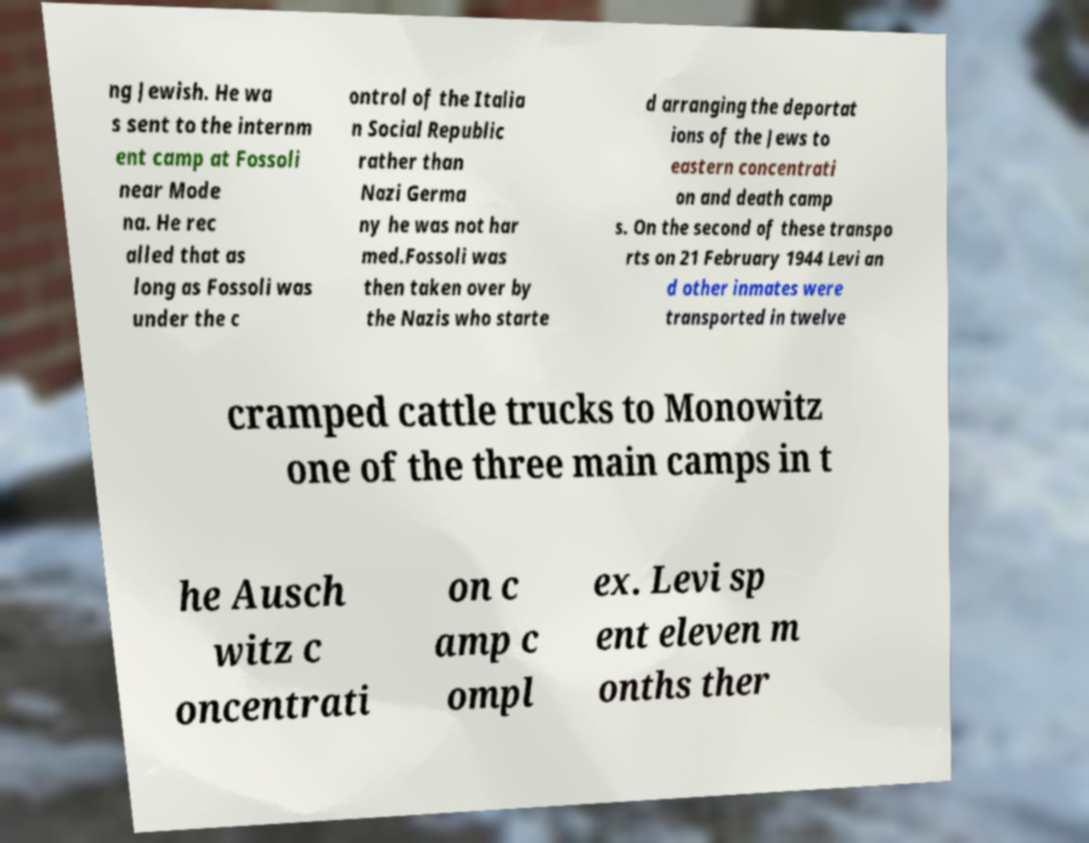Could you assist in decoding the text presented in this image and type it out clearly? ng Jewish. He wa s sent to the internm ent camp at Fossoli near Mode na. He rec alled that as long as Fossoli was under the c ontrol of the Italia n Social Republic rather than Nazi Germa ny he was not har med.Fossoli was then taken over by the Nazis who starte d arranging the deportat ions of the Jews to eastern concentrati on and death camp s. On the second of these transpo rts on 21 February 1944 Levi an d other inmates were transported in twelve cramped cattle trucks to Monowitz one of the three main camps in t he Ausch witz c oncentrati on c amp c ompl ex. Levi sp ent eleven m onths ther 